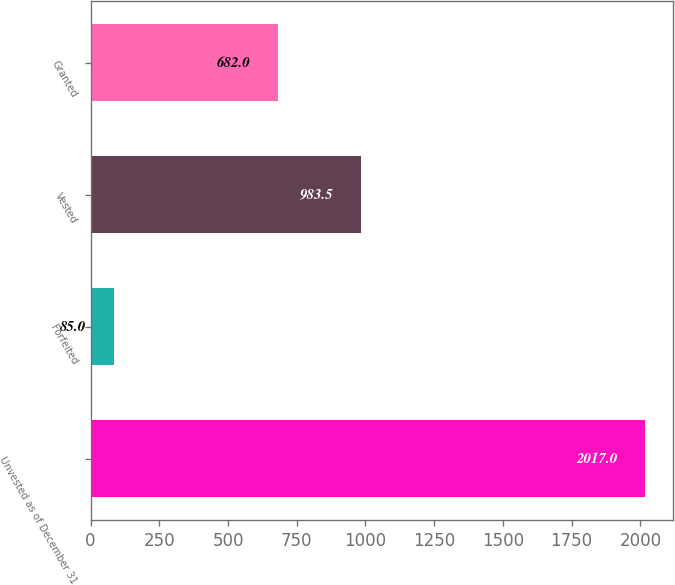Convert chart to OTSL. <chart><loc_0><loc_0><loc_500><loc_500><bar_chart><fcel>Unvested as of December 31<fcel>Forfeited<fcel>Vested<fcel>Granted<nl><fcel>2017<fcel>85<fcel>983.5<fcel>682<nl></chart> 